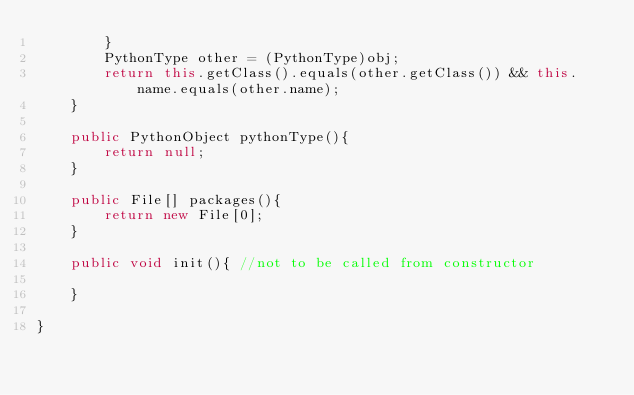<code> <loc_0><loc_0><loc_500><loc_500><_Java_>        }
        PythonType other = (PythonType)obj;
        return this.getClass().equals(other.getClass()) && this.name.equals(other.name);
    }

    public PythonObject pythonType(){
        return null;
    }

    public File[] packages(){
        return new File[0];
    }

    public void init(){ //not to be called from constructor

    }

}
</code> 